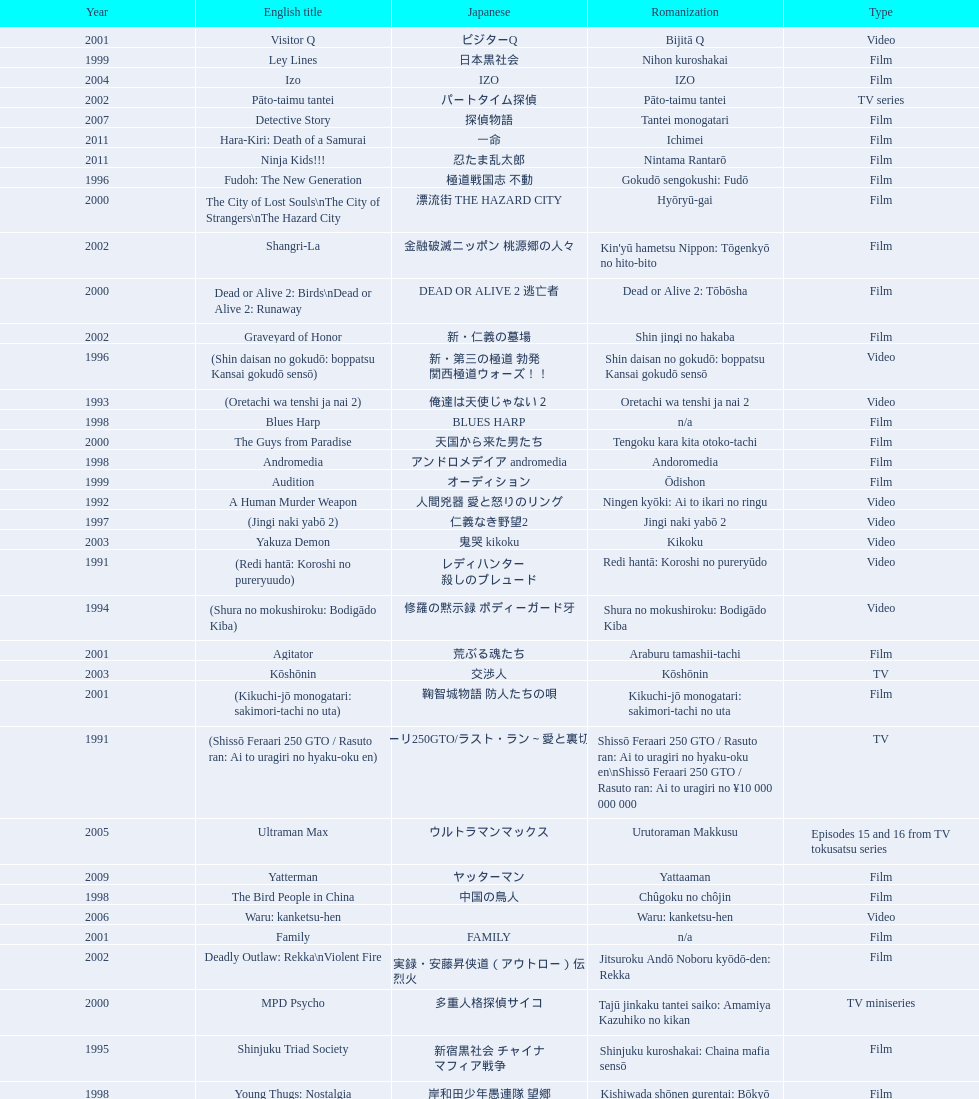Write the full table. {'header': ['Year', 'English title', 'Japanese', 'Romanization', 'Type'], 'rows': [['2001', 'Visitor Q', 'ビジターQ', 'Bijitā Q', 'Video'], ['1999', 'Ley Lines', '日本黒社会', 'Nihon kuroshakai', 'Film'], ['2004', 'Izo', 'IZO', 'IZO', 'Film'], ['2002', 'Pāto-taimu tantei', 'パートタイム探偵', 'Pāto-taimu tantei', 'TV series'], ['2007', 'Detective Story', '探偵物語', 'Tantei monogatari', 'Film'], ['2011', 'Hara-Kiri: Death of a Samurai', '一命', 'Ichimei', 'Film'], ['2011', 'Ninja Kids!!!', '忍たま乱太郎', 'Nintama Rantarō', 'Film'], ['1996', 'Fudoh: The New Generation', '極道戦国志 不動', 'Gokudō sengokushi: Fudō', 'Film'], ['2000', 'The City of Lost Souls\\nThe City of Strangers\\nThe Hazard City', '漂流街 THE HAZARD CITY', 'Hyōryū-gai', 'Film'], ['2002', 'Shangri-La', '金融破滅ニッポン 桃源郷の人々', "Kin'yū hametsu Nippon: Tōgenkyō no hito-bito", 'Film'], ['2000', 'Dead or Alive 2: Birds\\nDead or Alive 2: Runaway', 'DEAD OR ALIVE 2 逃亡者', 'Dead or Alive 2: Tōbōsha', 'Film'], ['2002', 'Graveyard of Honor', '新・仁義の墓場', 'Shin jingi no hakaba', 'Film'], ['1996', '(Shin daisan no gokudō: boppatsu Kansai gokudō sensō)', '新・第三の極道 勃発 関西極道ウォーズ！！', 'Shin daisan no gokudō: boppatsu Kansai gokudō sensō', 'Video'], ['1993', '(Oretachi wa tenshi ja nai 2)', '俺達は天使じゃない２', 'Oretachi wa tenshi ja nai 2', 'Video'], ['1998', 'Blues Harp', 'BLUES HARP', 'n/a', 'Film'], ['2000', 'The Guys from Paradise', '天国から来た男たち', 'Tengoku kara kita otoko-tachi', 'Film'], ['1998', 'Andromedia', 'アンドロメデイア andromedia', 'Andoromedia', 'Film'], ['1999', 'Audition', 'オーディション', 'Ōdishon', 'Film'], ['1992', 'A Human Murder Weapon', '人間兇器 愛と怒りのリング', 'Ningen kyōki: Ai to ikari no ringu', 'Video'], ['1997', '(Jingi naki yabō 2)', '仁義なき野望2', 'Jingi naki yabō 2', 'Video'], ['2003', 'Yakuza Demon', '鬼哭 kikoku', 'Kikoku', 'Video'], ['1991', '(Redi hantā: Koroshi no pureryuudo)', 'レディハンター 殺しのプレュード', 'Redi hantā: Koroshi no pureryūdo', 'Video'], ['1994', '(Shura no mokushiroku: Bodigādo Kiba)', '修羅の黙示録 ボディーガード牙', 'Shura no mokushiroku: Bodigādo Kiba', 'Video'], ['2001', 'Agitator', '荒ぶる魂たち', 'Araburu tamashii-tachi', 'Film'], ['2003', 'Kōshōnin', '交渉人', 'Kōshōnin', 'TV'], ['2001', '(Kikuchi-jō monogatari: sakimori-tachi no uta)', '鞠智城物語 防人たちの唄', 'Kikuchi-jō monogatari: sakimori-tachi no uta', 'Film'], ['1991', '(Shissō Feraari 250 GTO / Rasuto ran: Ai to uragiri no hyaku-oku en)', '疾走フェラーリ250GTO/ラスト・ラン～愛と裏切りの百億円', 'Shissō Feraari 250 GTO / Rasuto ran: Ai to uragiri no hyaku-oku en\\nShissō Feraari 250 GTO / Rasuto ran: Ai to uragiri no ¥10 000 000 000', 'TV'], ['2005', 'Ultraman Max', 'ウルトラマンマックス', 'Urutoraman Makkusu', 'Episodes 15 and 16 from TV tokusatsu series'], ['2009', 'Yatterman', 'ヤッターマン', 'Yattaaman', 'Film'], ['1998', 'The Bird People in China', '中国の鳥人', 'Chûgoku no chôjin', 'Film'], ['2006', 'Waru: kanketsu-hen', '', 'Waru: kanketsu-hen', 'Video'], ['2001', 'Family', 'FAMILY', 'n/a', 'Film'], ['2002', 'Deadly Outlaw: Rekka\\nViolent Fire', '実録・安藤昇侠道（アウトロー）伝 烈火', 'Jitsuroku Andō Noboru kyōdō-den: Rekka', 'Film'], ['2000', 'MPD Psycho', '多重人格探偵サイコ', 'Tajū jinkaku tantei saiko: Amamiya Kazuhiko no kikan', 'TV miniseries'], ['1995', 'Shinjuku Triad Society', '新宿黒社会 チャイナ マフィア戦争', 'Shinjuku kuroshakai: Chaina mafia sensō', 'Film'], ['1998', 'Young Thugs: Nostalgia', '岸和田少年愚連隊 望郷', 'Kishiwada shōnen gurentai: Bōkyō', 'Film'], ['1996', '(Piinattsu: Rakkasei)', 'ピイナッツ 落華星', 'Piinattsu: Rakkasei', 'Video'], ['1999', 'Man, A Natural Girl', '天然少女萬', 'Tennen shōjo Man', 'TV'], ['2007', 'Sukiyaki Western Django', 'スキヤキ・ウエスタン ジャンゴ', 'Sukiyaki wesutān jango', 'Film'], ['2005', 'The Great Yokai War', '妖怪大戦争', 'Yokai Daisenso', 'Film'], ['2007', 'Like a Dragon', '龍が如く 劇場版', 'Ryu ga Gotoku Gekijōban', 'Film'], ['1996', '(Jingi naki yabō)', '仁義なき野望', 'Jingi naki yabō', 'Video'], ['2003', "One Missed Call\\nYou've Got a Call", '着信アリ', 'Chakushin Ari', 'Film'], ['1994', 'Shinjuku Outlaw', '新宿アウトロー', 'Shinjuku autorou', 'Video'], ['2003', 'Gozu', '極道恐怖大劇場 牛頭 GOZU', 'Gokudō kyōfu dai-gekijō: Gozu', 'Film'], ['1999', 'Silver', 'シルバー SILVER', 'Silver: shirubā', 'Video'], ['1999', 'Salaryman Kintaro\\nWhite Collar Worker Kintaro', 'サラリーマン金太郎', 'Sarariiman Kintarō', 'Film'], ['1999', 'Dead or Alive', 'DEAD OR ALIVE 犯罪者', 'Dead or Alive: Hanzaisha', 'Film'], ['1993', '(Oretachi wa tenshi ja nai)', '俺達は天使じゃない', 'Oretachi wa tenshi ja nai', 'Video'], ['1999', 'Man, Next Natural Girl: 100 Nights In Yokohama\\nN-Girls vs Vampire', '天然少女萬NEXT 横浜百夜篇', 'Tennen shōjo Man next: Yokohama hyaku-ya hen', 'TV'], ['1996', 'The Way to Fight', '喧嘩の花道 大阪最強伝説', 'Kenka no hanamichi: Ōsaka saikyō densetsu', 'Video'], ['1995', 'Osaka Tough Guys', 'なにわ遊侠伝', 'Naniwa yūkyōden', 'Video'], ['2002', 'Dead or Alive: Final', 'DEAD OR ALIVE FINAL', 'n/a', 'Film'], ['2012', 'Ace Attorney', '逆転裁判', 'Gyakuten Saiban', 'Film'], ['2004', 'Box segment in Three... Extremes', 'BOX（『美しい夜、残酷な朝』）', 'Saam gaang yi', 'Segment in feature film'], ['2006', 'Imprint episode from Masters of Horror', 'インプリント ～ぼっけえ、きょうてえ～', 'Inpurinto ~bokke kyote~', 'TV episode'], ['2008', "God's Puzzle", '神様のパズル', 'Kamisama no pazuru', 'Film'], ['1995', '(Shura no mokushiroku 2: Bodigādo Kiba)', '修羅の黙示録2 ボディーガード牙', 'Shura no mokushiroku 2: Bodigādo Kiba', 'Video'], ['2004', 'Zebraman', 'ゼブラーマン', 'Zeburāman', 'Film'], ['2002', 'Sabu', 'SABU さぶ', 'Sabu', 'TV'], ['2004', 'Pāto-taimu tantei 2', 'パートタイム探偵2', 'Pāto-taimu tantei 2', 'TV'], ['1996', '(Shin daisan no gokudō II)', '新・第三の極道II', 'Shin daisan no gokudō II', 'Video'], ['1997', 'Full Metal Yakuza', 'FULL METAL 極道', 'Full Metal gokudō', 'Video'], ['1993', 'Bodyguard Kiba', 'ボディガード牙', 'Bodigādo Kiba', 'Video'], ['2008', 'K-tai Investigator 7', 'ケータイ捜査官7', 'Keitai Sōsakan 7', 'TV'], ['2006', 'Big Bang Love, Juvenile A\\n4.6 Billion Years of Love', '46億年の恋', '46-okunen no koi', 'Film'], ['1995', '(Daisan no gokudō)', '第三の極道', 'Daisan no gokudō', 'Video'], ['2002', '(Onna kunishū ikki)', 'おんな 国衆一揆', 'Onna kunishū ikki', '(unknown)'], ['2001', 'The Happiness of the Katakuris', 'カタクリ家の幸福', 'Katakuri-ke no kōfuku', 'Film'], ['2012', 'Lesson of the Evil', '悪の教典', 'Aku no Kyōten', 'Film'], ['2012', "For Love's Sake", '愛と誠', 'Ai to makoto', 'Film'], ['2006', 'Sun Scarred', '太陽の傷', 'Taiyo no kizu', 'Film'], ['2010', 'Thirteen Assassins', '十三人の刺客', 'Jûsan-nin no shikaku', 'Film'], ['2013', 'The Mole Song: Undercover Agent Reiji', '土竜の唄\u3000潜入捜査官 REIJI', 'Mogura no uta – sennyu sosakan: Reiji', 'Film'], ['1997', 'Young Thugs: Innocent Blood', '岸和田少年愚連隊 血煙り純情篇', 'Kishiwada shōnen gurentai: Chikemuri junjō-hen', 'Film'], ['2000', "The Making of 'Gemini'", '(unknown)', "Tsukamoto Shin'ya ga Ranpo suru", 'TV documentary'], ['2001', '(Zuiketsu gensō: Tonkararin yume densetsu)', '隧穴幻想 トンカラリン夢伝説', 'Zuiketsu gensō: Tonkararin yume densetsu', 'Film'], ['1991', '(Toppū! Minipato tai - Aikyacchi Jankushon)', '突風！ ミニパト隊 アイキャッチ・ジャンクション', 'Toppū! Minipato tai - Aikyatchi Jankushon', 'Video'], ['2010', 'Zebraman 2: Attack on Zebra City', 'ゼブラーマン -ゼブラシティの逆襲', 'Zeburāman -Zebura Shiti no Gyakushū', 'Film'], ['2006', 'Waru', 'WARU', 'Waru', 'Film'], ['2003', 'The Man in White', '許されざる者', 'Yurusarezaru mono', 'Film'], ['2002', 'Pandōra', 'パンドーラ', 'Pandōra', 'Music video'], ['2007', 'Zatoichi', '座頭市', 'Zatōichi', 'Stageplay'], ['1997', 'Rainy Dog', '極道黒社会 RAINY DOG', 'Gokudō kuroshakai', 'Film'], ['2013', 'Shield of Straw', '藁の楯', 'Wara no Tate', 'Film'], ['2001', 'Ichi the Killer', '殺し屋1', 'Koroshiya 1', 'Film'], ['2009', 'Crows Zero 2', 'クローズZERO 2', 'Kurōzu Zero 2', 'Film'], ['2007', 'Crows Zero', 'クローズZERO', 'Kurōzu Zero', 'Film']]} Was shinjuku triad society a film or tv release? Film. 